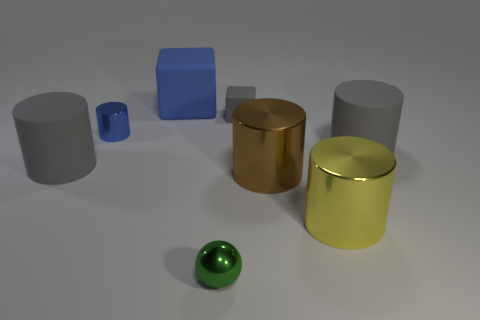There is a tiny thing to the right of the green sphere; is it the same shape as the blue matte object?
Your answer should be very brief. Yes. Are there more small blue metallic things that are to the right of the yellow metal cylinder than blue rubber cylinders?
Offer a very short reply. No. Are there any other things that have the same material as the big brown cylinder?
Keep it short and to the point. Yes. There is a rubber thing that is the same color as the tiny cylinder; what is its shape?
Keep it short and to the point. Cube. How many blocks are brown metallic things or small metal things?
Provide a succinct answer. 0. There is a big matte object right of the cylinder that is in front of the brown metal cylinder; what is its color?
Make the answer very short. Gray. Is the color of the small matte cube the same as the metallic thing that is on the left side of the large rubber cube?
Offer a very short reply. No. There is a blue object that is made of the same material as the gray block; what is its size?
Your answer should be very brief. Large. There is a shiny cylinder that is the same color as the large cube; what size is it?
Offer a very short reply. Small. Is the color of the tiny cylinder the same as the big matte block?
Make the answer very short. Yes. 